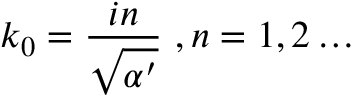Convert formula to latex. <formula><loc_0><loc_0><loc_500><loc_500>k _ { 0 } = \frac { i n } { \sqrt { \alpha ^ { \prime } } } \ , n = 1 , 2 \dots</formula> 